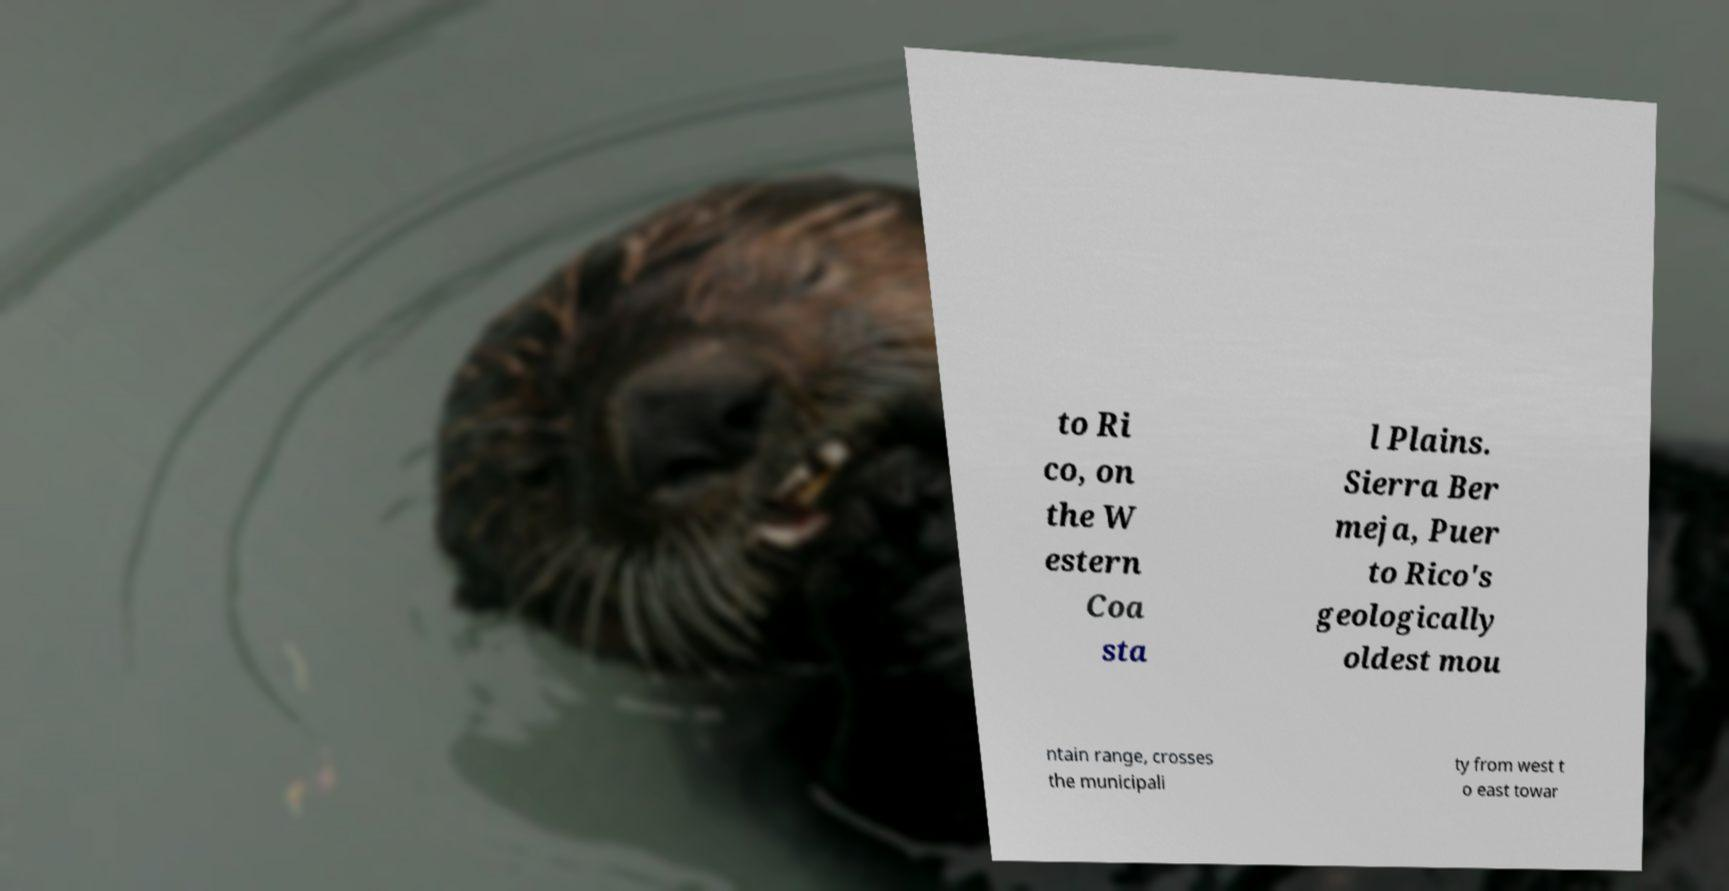Could you assist in decoding the text presented in this image and type it out clearly? to Ri co, on the W estern Coa sta l Plains. Sierra Ber meja, Puer to Rico's geologically oldest mou ntain range, crosses the municipali ty from west t o east towar 